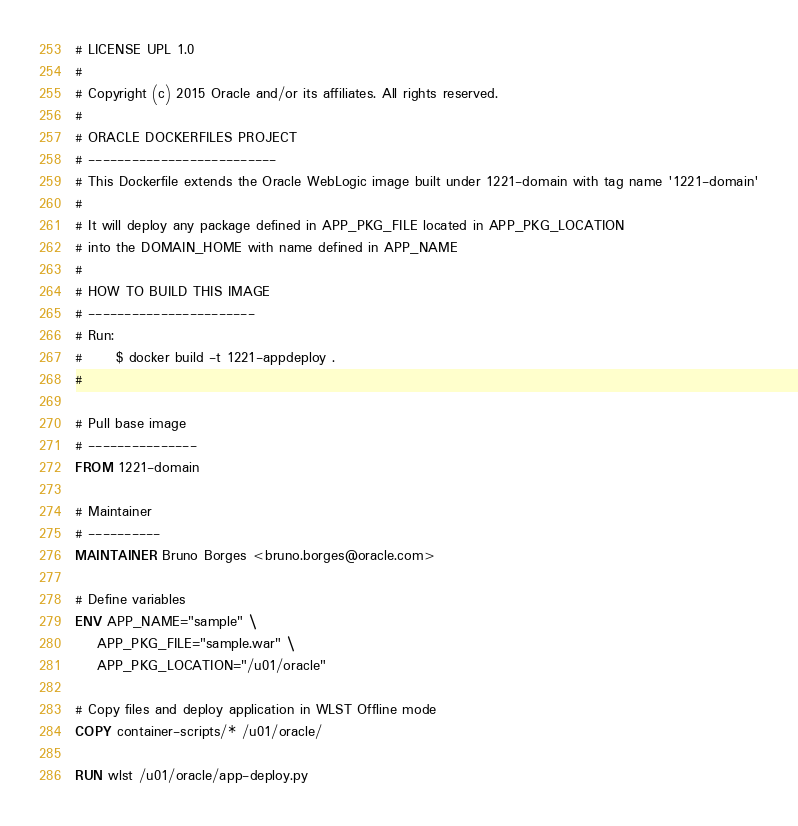<code> <loc_0><loc_0><loc_500><loc_500><_Dockerfile_># LICENSE UPL 1.0
#
# Copyright (c) 2015 Oracle and/or its affiliates. All rights reserved.
# 
# ORACLE DOCKERFILES PROJECT
# --------------------------
# This Dockerfile extends the Oracle WebLogic image built under 1221-domain with tag name '1221-domain'
#
# It will deploy any package defined in APP_PKG_FILE located in APP_PKG_LOCATION
# into the DOMAIN_HOME with name defined in APP_NAME
#
# HOW TO BUILD THIS IMAGE
# -----------------------
# Run: 
#      $ docker build -t 1221-appdeploy .
#

# Pull base image
# ---------------
FROM 1221-domain 

# Maintainer
# ----------
MAINTAINER Bruno Borges <bruno.borges@oracle.com>

# Define variables
ENV APP_NAME="sample" \
    APP_PKG_FILE="sample.war" \
    APP_PKG_LOCATION="/u01/oracle"

# Copy files and deploy application in WLST Offline mode
COPY container-scripts/* /u01/oracle/

RUN wlst /u01/oracle/app-deploy.py
</code> 